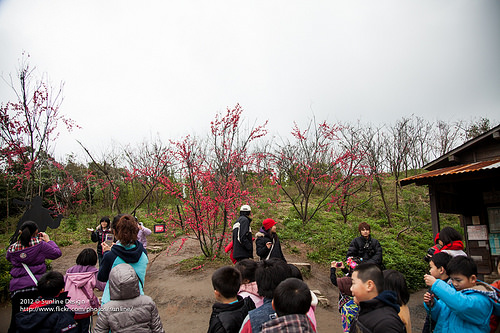<image>
Is the jacket on the person? No. The jacket is not positioned on the person. They may be near each other, but the jacket is not supported by or resting on top of the person. 